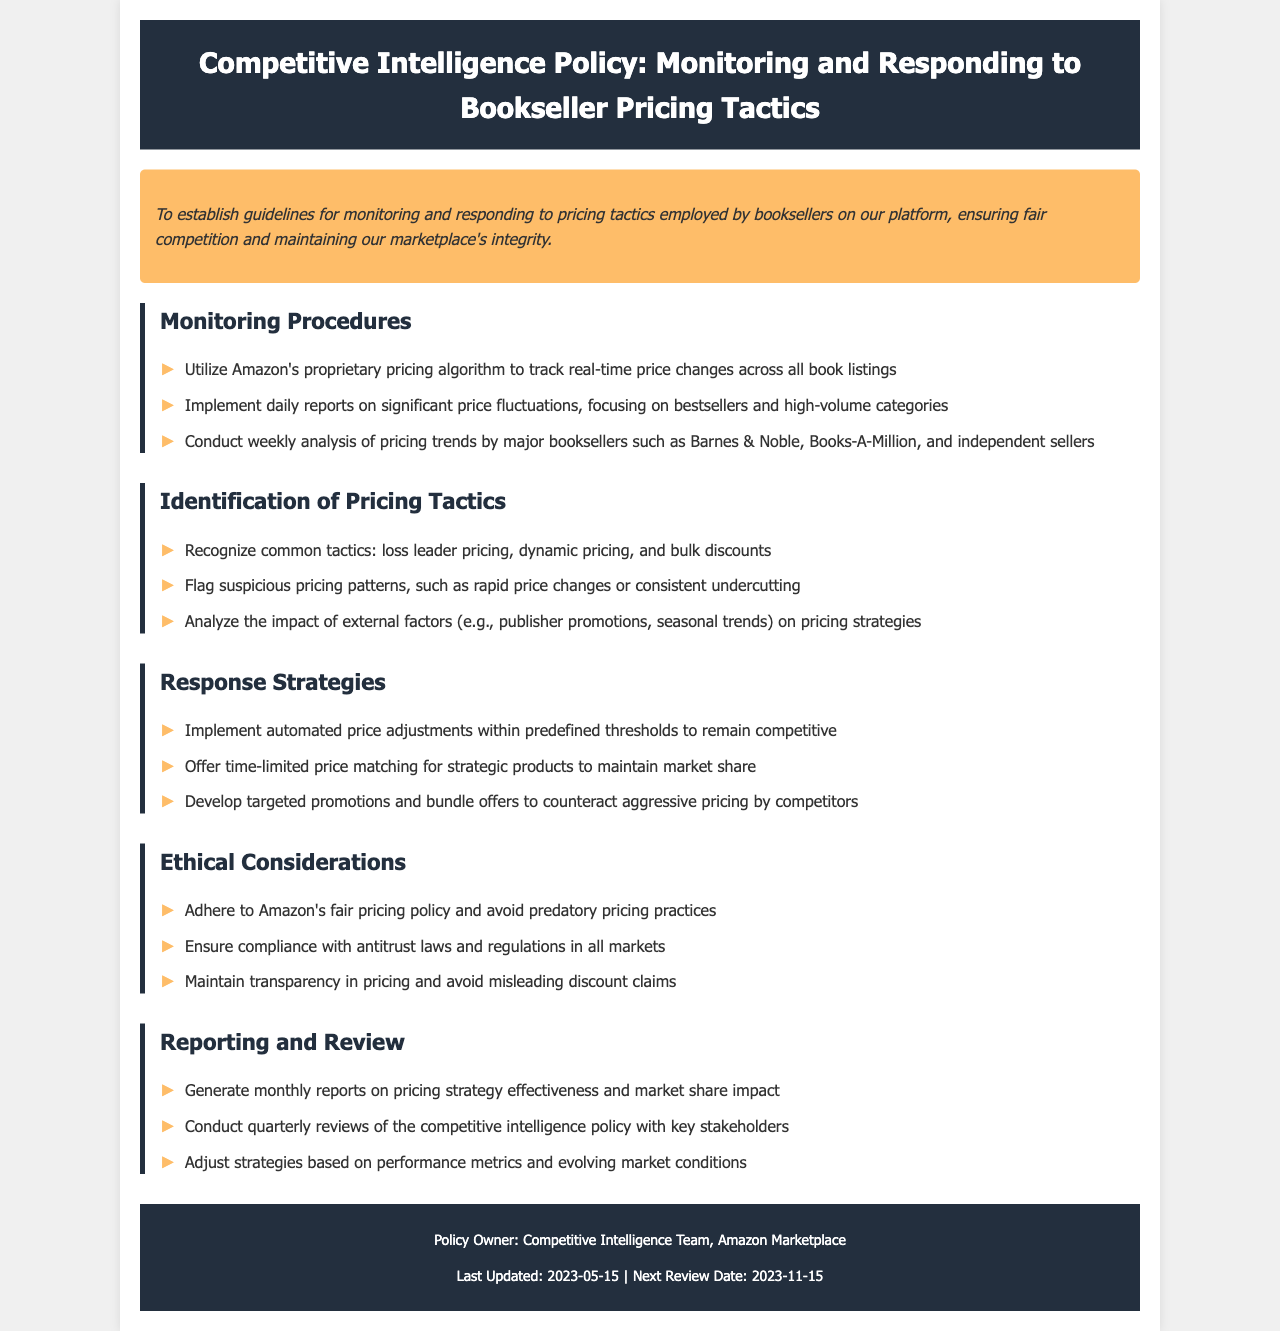What is the purpose of the policy? The purpose of the policy is stated in the document as establishing guidelines for monitoring and responding to pricing tactics employed by booksellers, ensuring fair competition and maintaining marketplace integrity.
Answer: To establish guidelines for monitoring and responding to pricing tactics employed by booksellers on our platform, ensuring fair competition and maintaining our marketplace's integrity Who are the major booksellers monitored? The document lists specific major booksellers whose pricing tactics are analyzed, which includes Barnes & Noble and Books-A-Million.
Answer: Barnes & Noble, Books-A-Million What is included in the monitoring procedures? The document outlines specific actions under monitoring procedures such as utilizing the proprietary pricing algorithm and conducting weekly analysis of pricing trends.
Answer: Utilize Amazon's proprietary pricing algorithm to track real-time price changes across all book listings What are some common pricing tactics recognized? The document discusses various pricing strategies used by competitors, including loss leader pricing, dynamic pricing, and bulk discounts.
Answer: loss leader pricing, dynamic pricing, and bulk discounts What is the frequency of reporting on pricing strategy effectiveness? According to the policy, reports on pricing strategy effectiveness are generated every month, indicating how often the strategies are reviewed.
Answer: monthly What is the last updated date of the policy? The document specifies the date when the policy was last updated, providing a clear reference for its recency.
Answer: 2023-05-15 Which team owns the policy? The document identifies the specific team responsible for this policy, pointing to the Competitive Intelligence Team within Amazon.
Answer: Competitive Intelligence Team, Amazon Marketplace What should be adhered to as part of ethical considerations? The policy emphasizes adherence to certain guidelines as ethical considerations which include avoiding predatory pricing practices.
Answer: Adhere to Amazon's fair pricing policy and avoid predatory pricing practices 